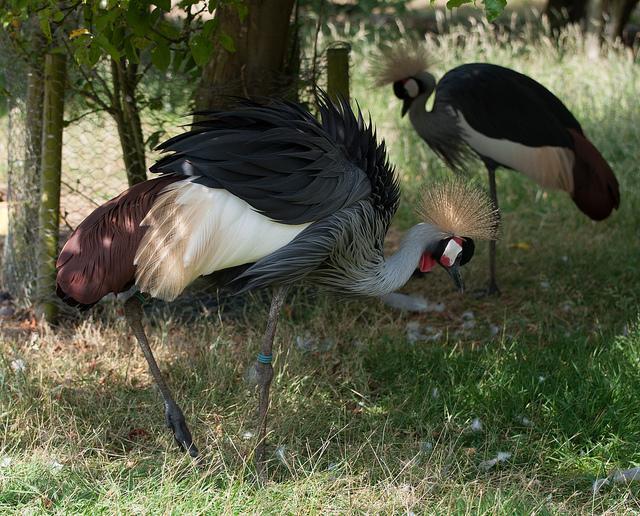How many birds are there?
Give a very brief answer. 2. 